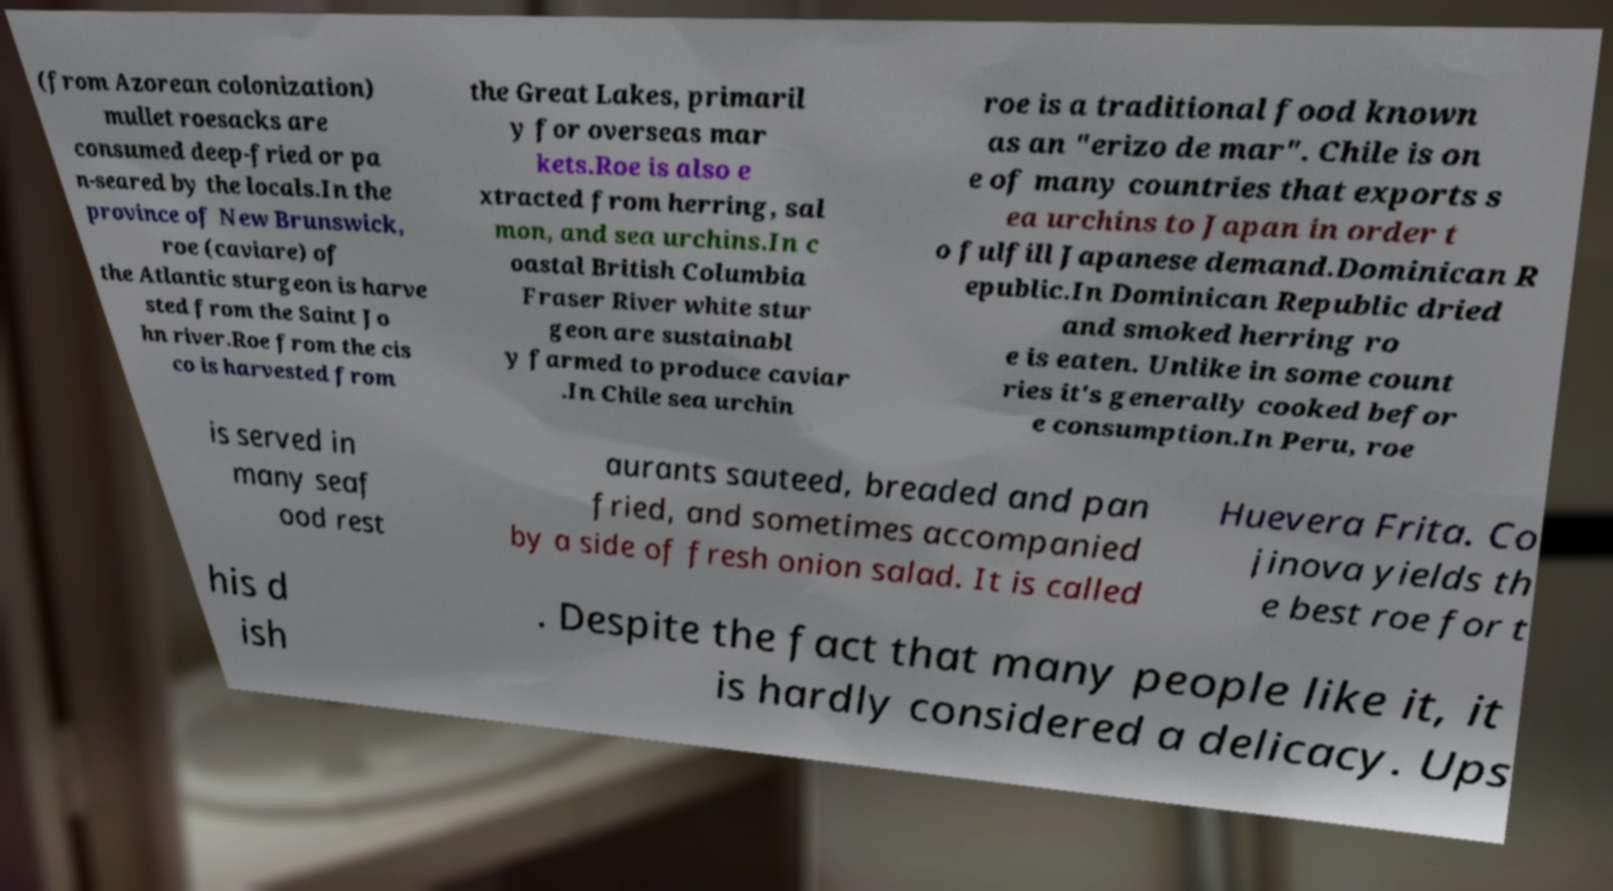Could you assist in decoding the text presented in this image and type it out clearly? (from Azorean colonization) mullet roesacks are consumed deep-fried or pa n-seared by the locals.In the province of New Brunswick, roe (caviare) of the Atlantic sturgeon is harve sted from the Saint Jo hn river.Roe from the cis co is harvested from the Great Lakes, primaril y for overseas mar kets.Roe is also e xtracted from herring, sal mon, and sea urchins.In c oastal British Columbia Fraser River white stur geon are sustainabl y farmed to produce caviar .In Chile sea urchin roe is a traditional food known as an "erizo de mar". Chile is on e of many countries that exports s ea urchins to Japan in order t o fulfill Japanese demand.Dominican R epublic.In Dominican Republic dried and smoked herring ro e is eaten. Unlike in some count ries it's generally cooked befor e consumption.In Peru, roe is served in many seaf ood rest aurants sauteed, breaded and pan fried, and sometimes accompanied by a side of fresh onion salad. It is called Huevera Frita. Co jinova yields th e best roe for t his d ish . Despite the fact that many people like it, it is hardly considered a delicacy. Ups 